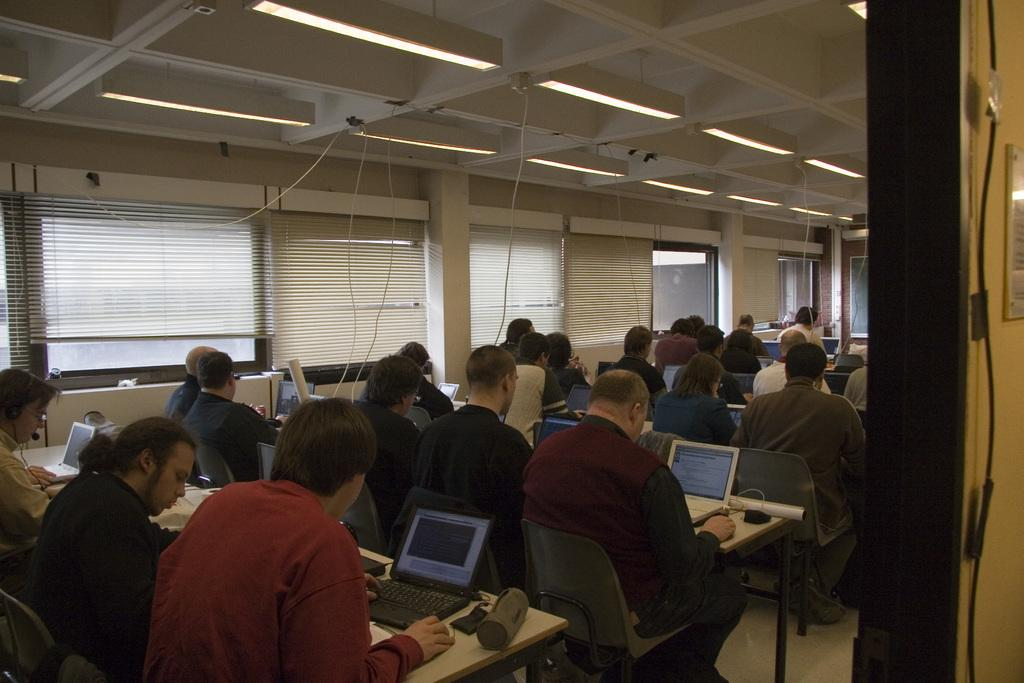What are the people in the image doing? The people in the image are sitting on chairs. What objects are in front of the people? There are tables in front of the people. What electronic devices are on the tables? There are laptops on the tables. What can be seen in the background of the image? There are windows visible in the background of the image. How does the bomb affect the people in the image? There is no bomb present in the image, so it cannot affect the people. 